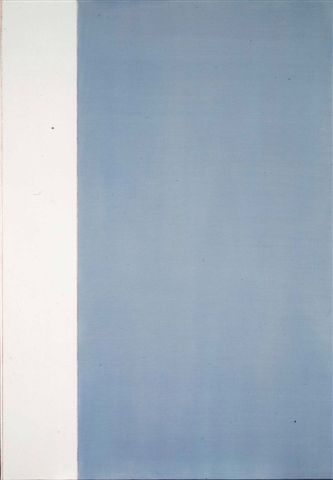This art piece is present in a notable museum. Describe a visitor's experience interacting with it. Upon entering the gallery, a visitor is immediately drawn to the large, captivating artwork. Positioned against a stark white wall, the piece's serene color palette creates a tranquil environment. As the visitor stands in front of it, they might feel a sense of calm wash over them, its minimalism inviting a break from the often overwhelming experiences of modern life. Moving closer, they notice subtle nuances in the blue gradient that weren’t apparent from a distance, perhaps evoking memories of the sky at different times of day. The visitor might spend several minutes, or even longer, contemplating the balance and dichotomy presented in the piece, losing themselves in its simplicity yet profound depth. What could be the artist's personal story behind creating this artwork? The artist might have created this piece as a representation of a pivotal moment in their life—a time of transition symbolized by the white and blue sections. The white could represent a period of emptiness or a new beginning, perhaps after a significant personal loss or a major life change. The gradient blue, lightening towards the top, may reflect their journey towards healing, enlightenment, and a brighter future. This artwork, therefore, stands as a deeply personal testament to their resilience and optimistic outlook, using simplicity to convey profound emotional depth. 